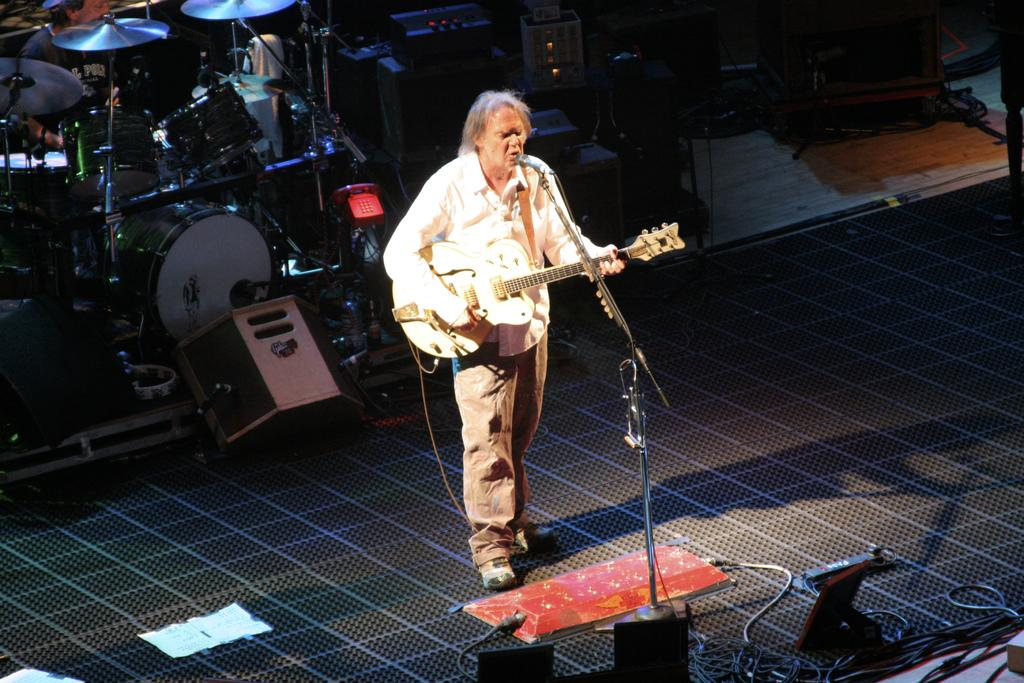What is the man doing on the stage in the image? The man is playing a guitar and singing on the stage. What object is the man using to amplify his voice? A: There is a microphone behind the man. What other musical instruments can be seen in the image? There are multiple musical instruments in the image. Is there any object in the image that is not related to music? Yes, there is a telephone in the image. What type of game is being played on the stage in the image? There is no game being played on the stage in the image; the man is playing a guitar and singing. Can you tell me how many buttons are on the man's shirt in the image? There is no information about the man's shirt or buttons in the provided facts, so it cannot be determined from the image. 